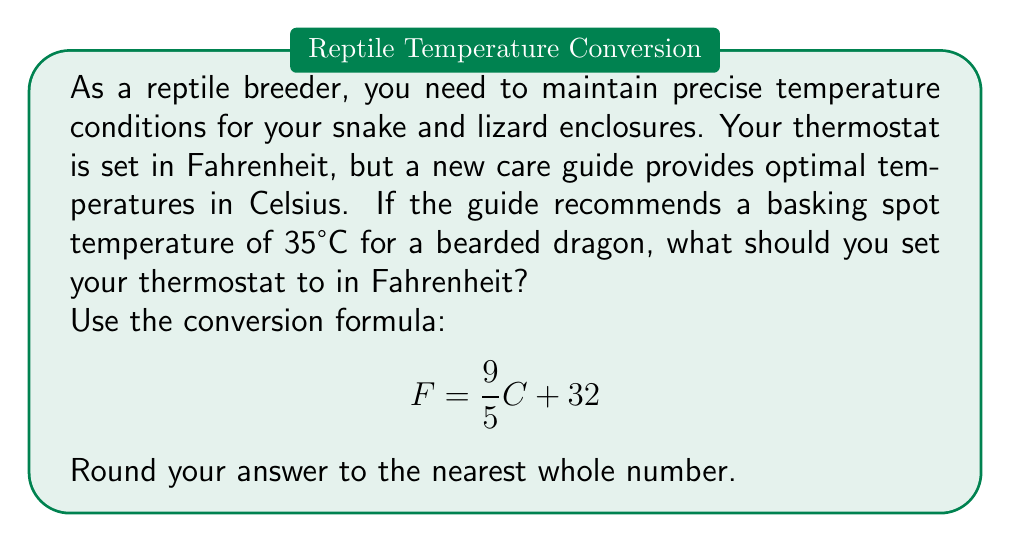Can you solve this math problem? To convert the temperature from Celsius to Fahrenheit, we'll use the given formula:

$$F = \frac{9}{5}C + 32$$

Where:
$F$ = Temperature in Fahrenheit
$C$ = Temperature in Celsius (35°C in this case)

Let's substitute the value and solve:

1) $$F = \frac{9}{5}(35) + 32$$

2) First, calculate $\frac{9}{5}(35)$:
   $$\frac{9}{5}(35) = \frac{315}{5} = 63$$

3) Now, add 32:
   $$F = 63 + 32 = 95$$

4) The result is exactly 95°F, so no rounding is necessary.

Therefore, you should set your thermostat to 95°F to achieve the recommended basking spot temperature of 35°C for your bearded dragon.
Answer: 95°F 